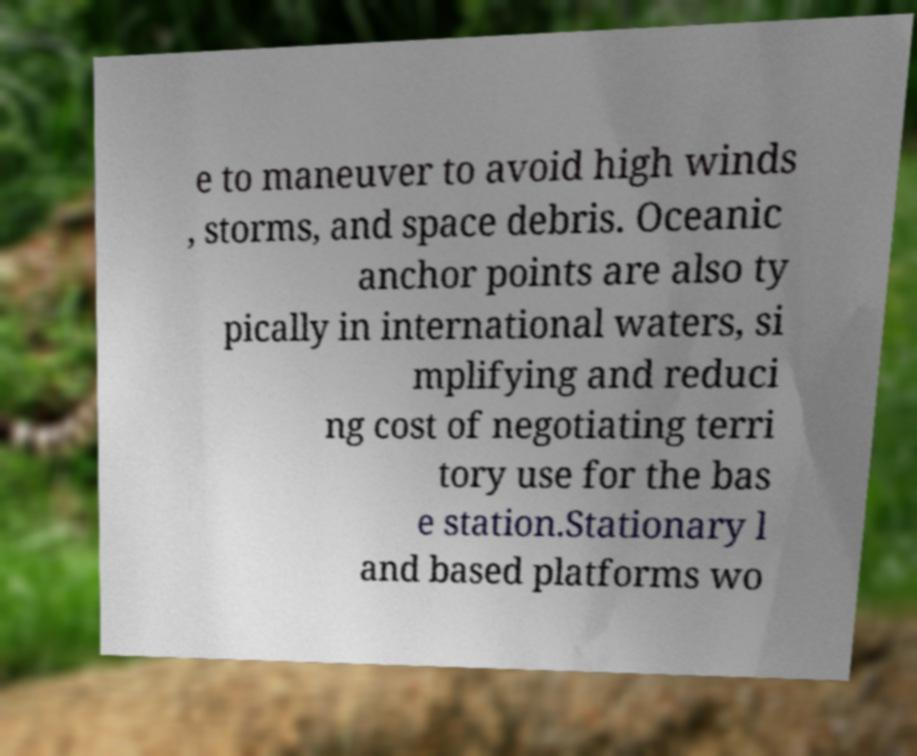Can you read and provide the text displayed in the image?This photo seems to have some interesting text. Can you extract and type it out for me? e to maneuver to avoid high winds , storms, and space debris. Oceanic anchor points are also ty pically in international waters, si mplifying and reduci ng cost of negotiating terri tory use for the bas e station.Stationary l and based platforms wo 